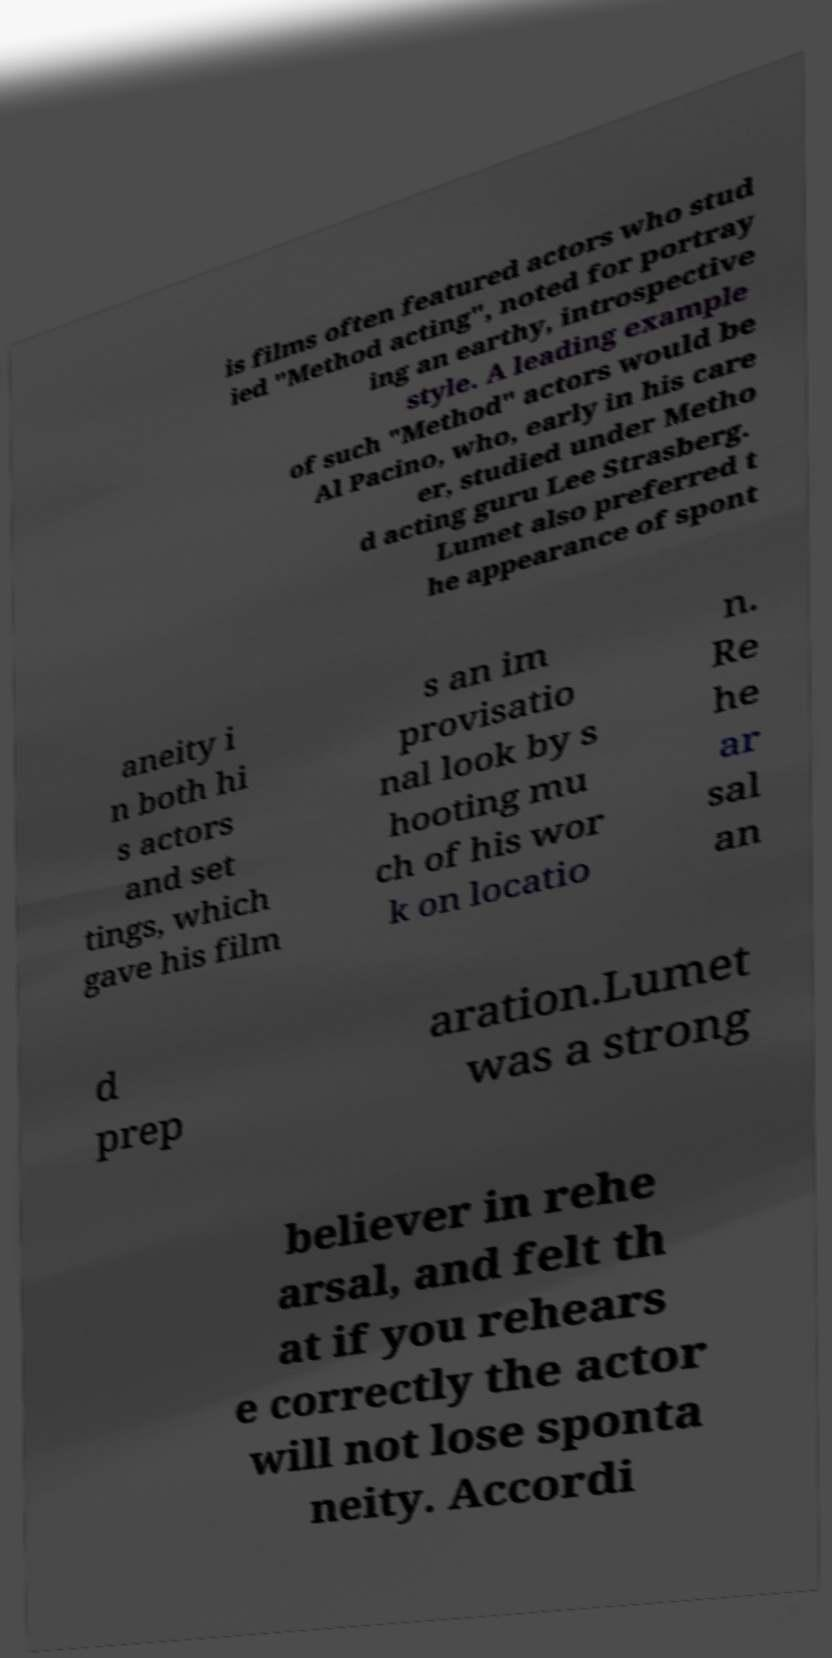I need the written content from this picture converted into text. Can you do that? is films often featured actors who stud ied "Method acting", noted for portray ing an earthy, introspective style. A leading example of such "Method" actors would be Al Pacino, who, early in his care er, studied under Metho d acting guru Lee Strasberg. Lumet also preferred t he appearance of spont aneity i n both hi s actors and set tings, which gave his film s an im provisatio nal look by s hooting mu ch of his wor k on locatio n. Re he ar sal an d prep aration.Lumet was a strong believer in rehe arsal, and felt th at if you rehears e correctly the actor will not lose sponta neity. Accordi 